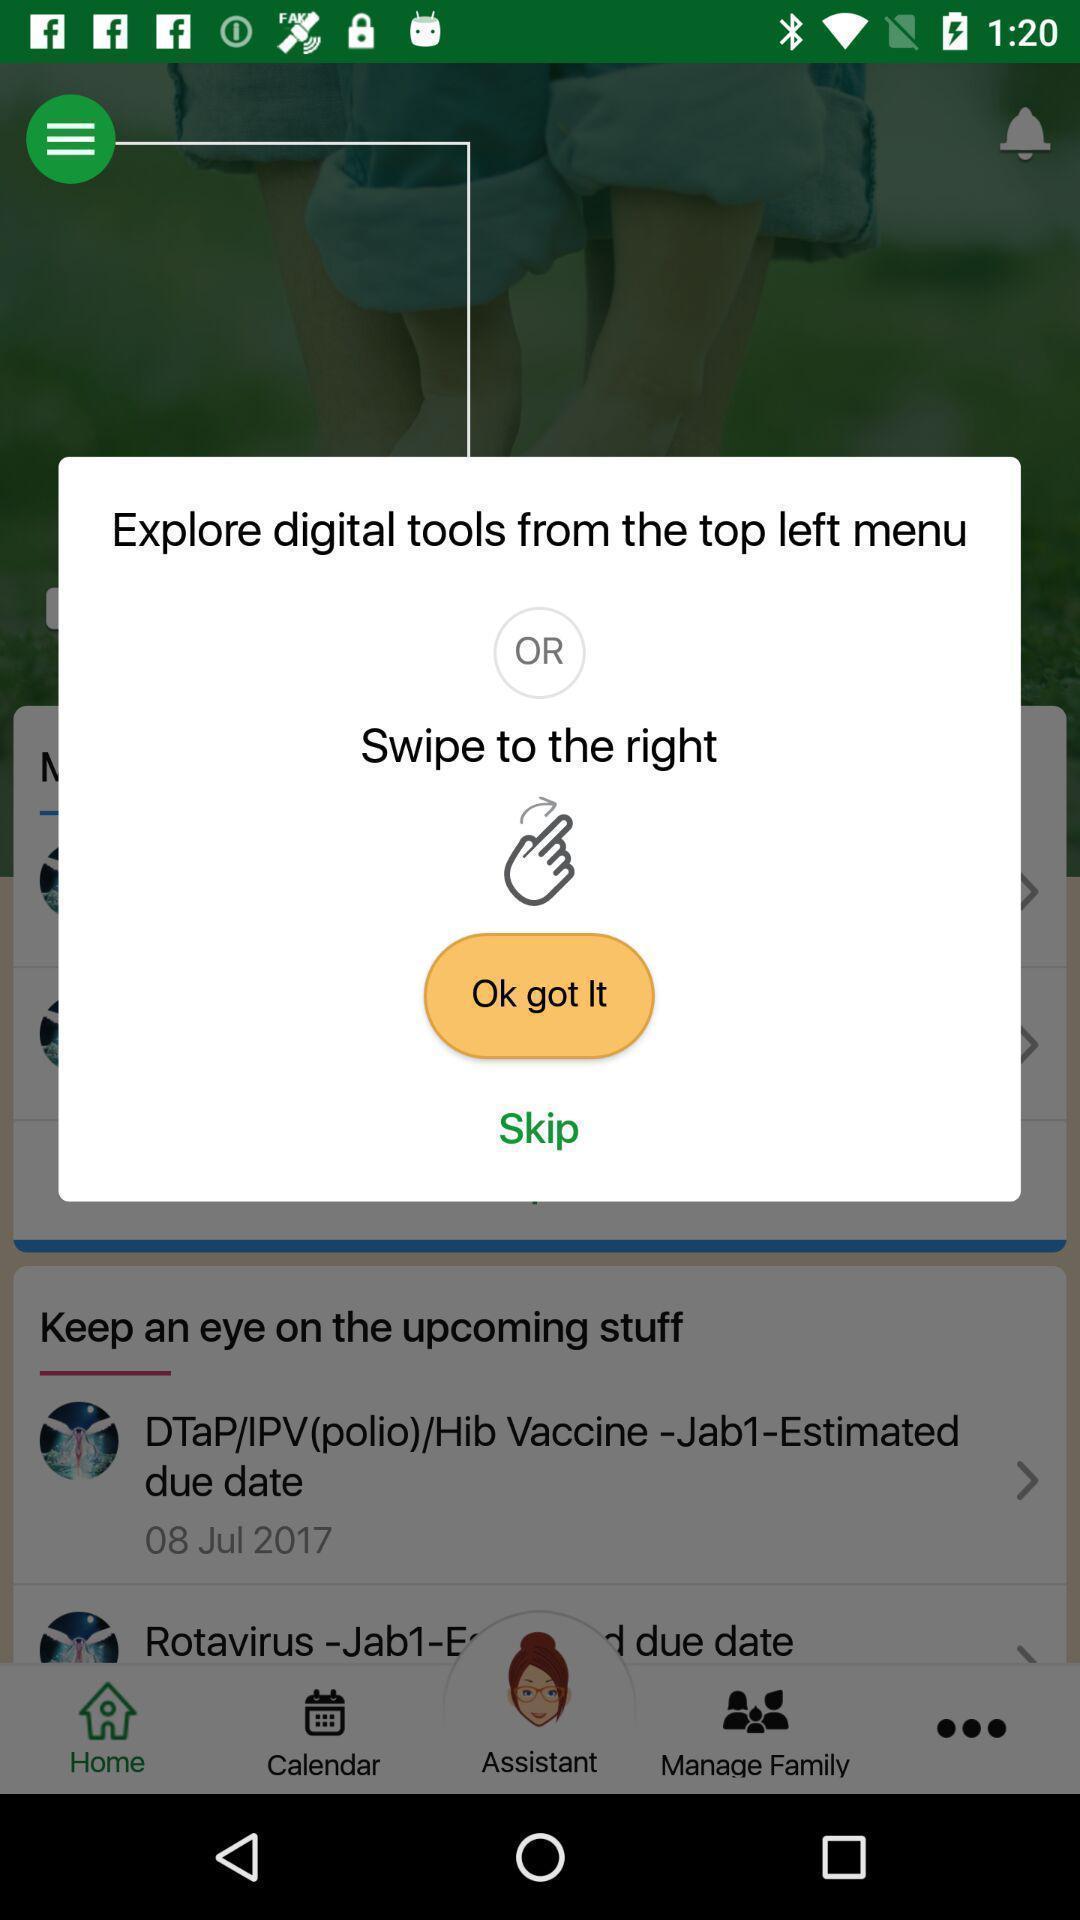Describe the key features of this screenshot. Popup of instruction to control the functioning of app. 